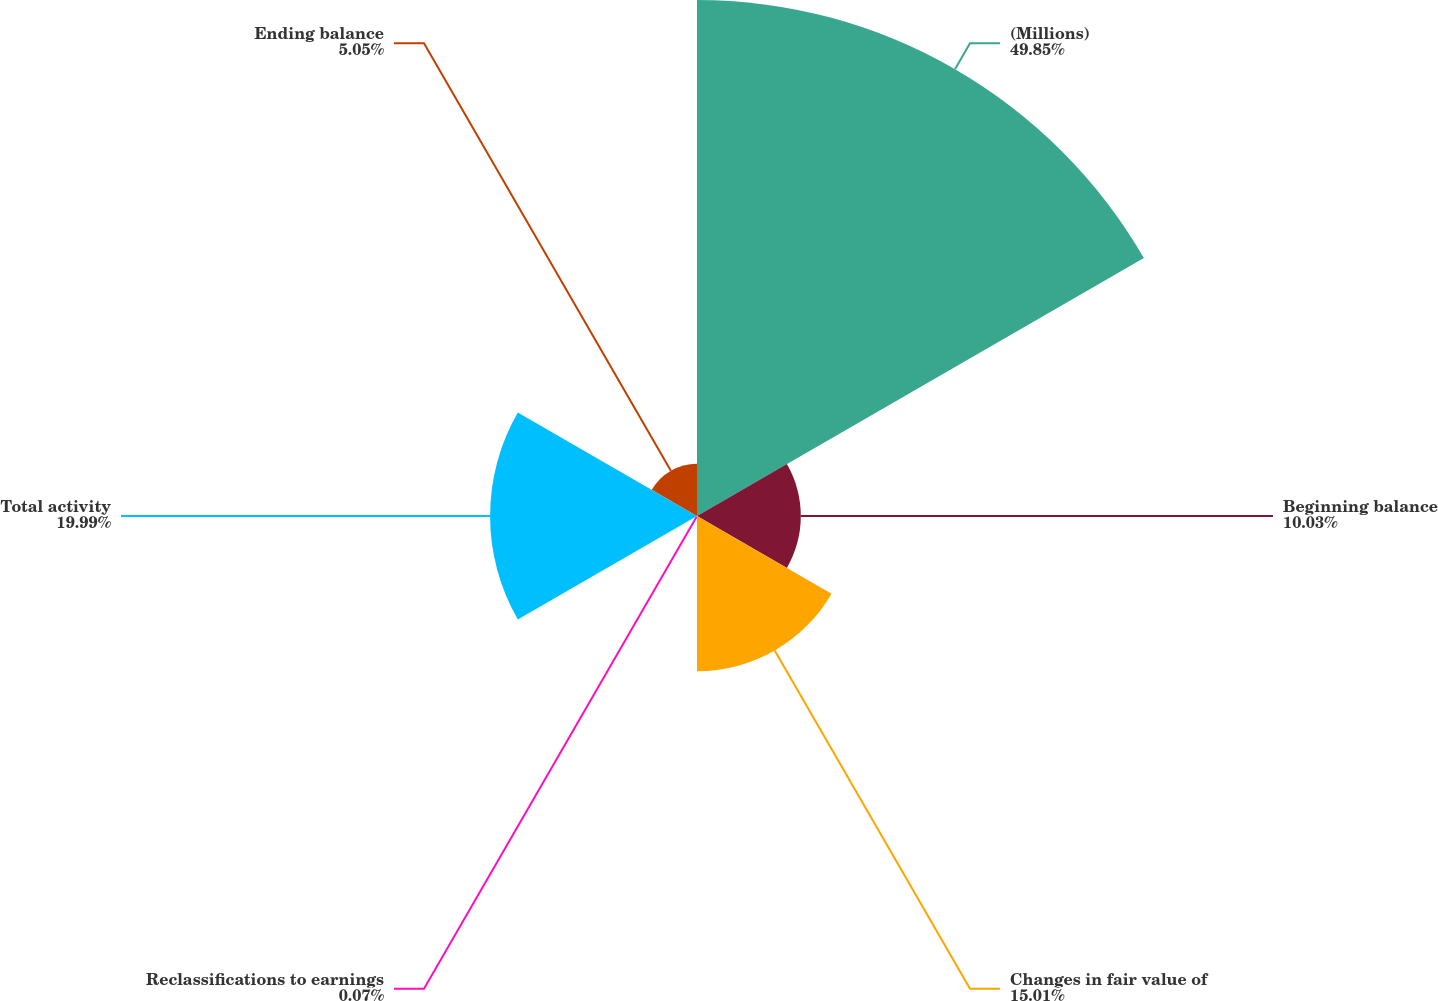<chart> <loc_0><loc_0><loc_500><loc_500><pie_chart><fcel>(Millions)<fcel>Beginning balance<fcel>Changes in fair value of<fcel>Reclassifications to earnings<fcel>Total activity<fcel>Ending balance<nl><fcel>49.85%<fcel>10.03%<fcel>15.01%<fcel>0.07%<fcel>19.99%<fcel>5.05%<nl></chart> 